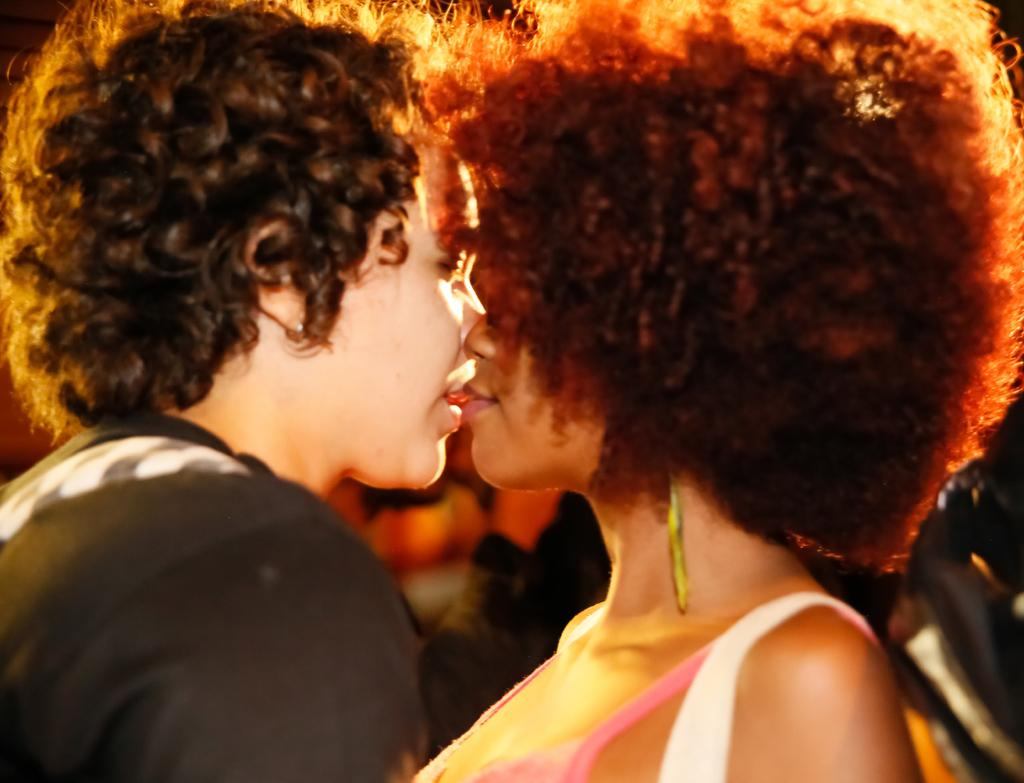How many people are in the image? There are two persons in the image. What is the gender of the people in the image? Both persons are women. What type of donkey can be seen in the image? There is no donkey present in the image. What is the cause of death for the person on the left side of the image? There is no indication of death or any medical condition in the image. 